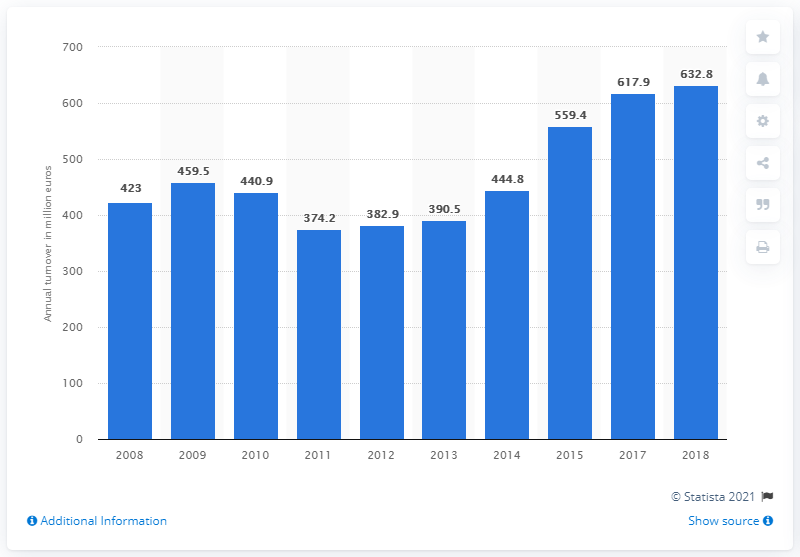List a handful of essential elements in this visual. The turnover of the building construction industry in Malta in 2017 was €617.9 million. The turnover of the building construction industry in Malta in 2017 was 632.8 million euros. 